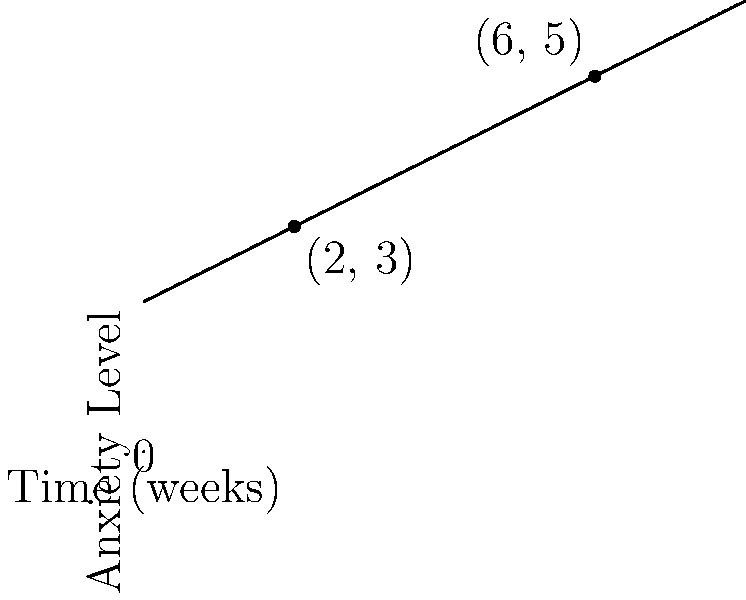The graph shows your anxiety levels over time. Two points are marked on the line: (2, 3) and (6, 5). Calculate the slope of the line connecting these two points. What does this slope represent in the context of your anxiety levels? To calculate the slope of the line, we'll use the slope formula:

$$ \text{Slope} = \frac{y_2 - y_1}{x_2 - x_1} $$

Where $(x_1, y_1)$ is the first point and $(x_2, y_2)$ is the second point.

Given points: (2, 3) and (6, 5)

Step 1: Identify the coordinates
$x_1 = 2$, $y_1 = 3$
$x_2 = 6$, $y_2 = 5$

Step 2: Apply the slope formula
$$ \text{Slope} = \frac{5 - 3}{6 - 2} = \frac{2}{4} = 0.5 $$

Step 3: Interpret the result
The slope is 0.5, which means for every 1 unit increase in time (1 week), the anxiety level increases by 0.5 units.

This positive slope indicates that your anxiety levels are increasing over time. Specifically, your anxiety level is rising by 0.5 units each week, showing a steady increase in your worry and stress levels.
Answer: Slope = 0.5; represents an increase of 0.5 anxiety units per week 